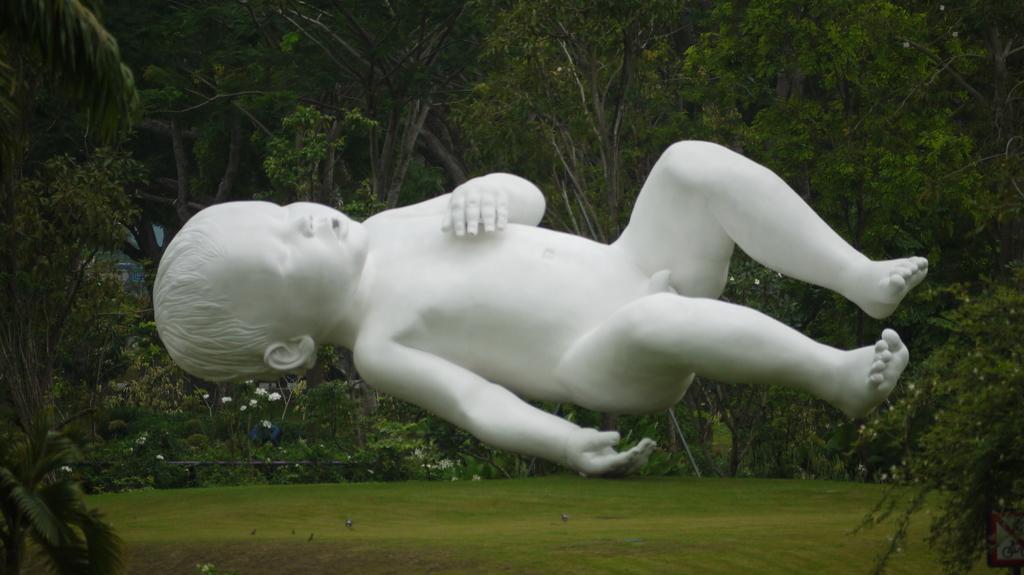Could you give a brief overview of what you see in this image? In this picture there is a statue of a baby. At the back there are trees and there are flowers and there is a railing. At the bottom there is grass. 